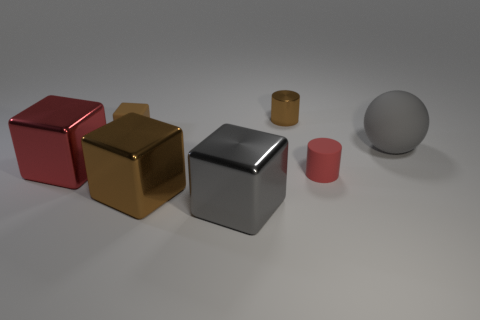There is a brown rubber object that is the same size as the red cylinder; what is its shape?
Offer a very short reply. Cube. What number of things are either matte things on the right side of the metallic cylinder or brown rubber things?
Give a very brief answer. 3. Is the color of the sphere the same as the rubber cylinder?
Provide a succinct answer. No. There is a cylinder in front of the sphere; what is its size?
Ensure brevity in your answer.  Small. Is there a green rubber object of the same size as the shiny cylinder?
Your answer should be very brief. No. There is a gray object in front of the gray ball; is it the same size as the gray matte ball?
Make the answer very short. Yes. How big is the red rubber object?
Provide a short and direct response. Small. There is a small rubber object left of the cube to the right of the large brown metal thing to the left of the tiny red cylinder; what is its color?
Your response must be concise. Brown. There is a rubber object left of the tiny metal object; is its color the same as the big sphere?
Ensure brevity in your answer.  No. How many things are both in front of the tiny brown metal object and on the left side of the big sphere?
Provide a short and direct response. 5. 